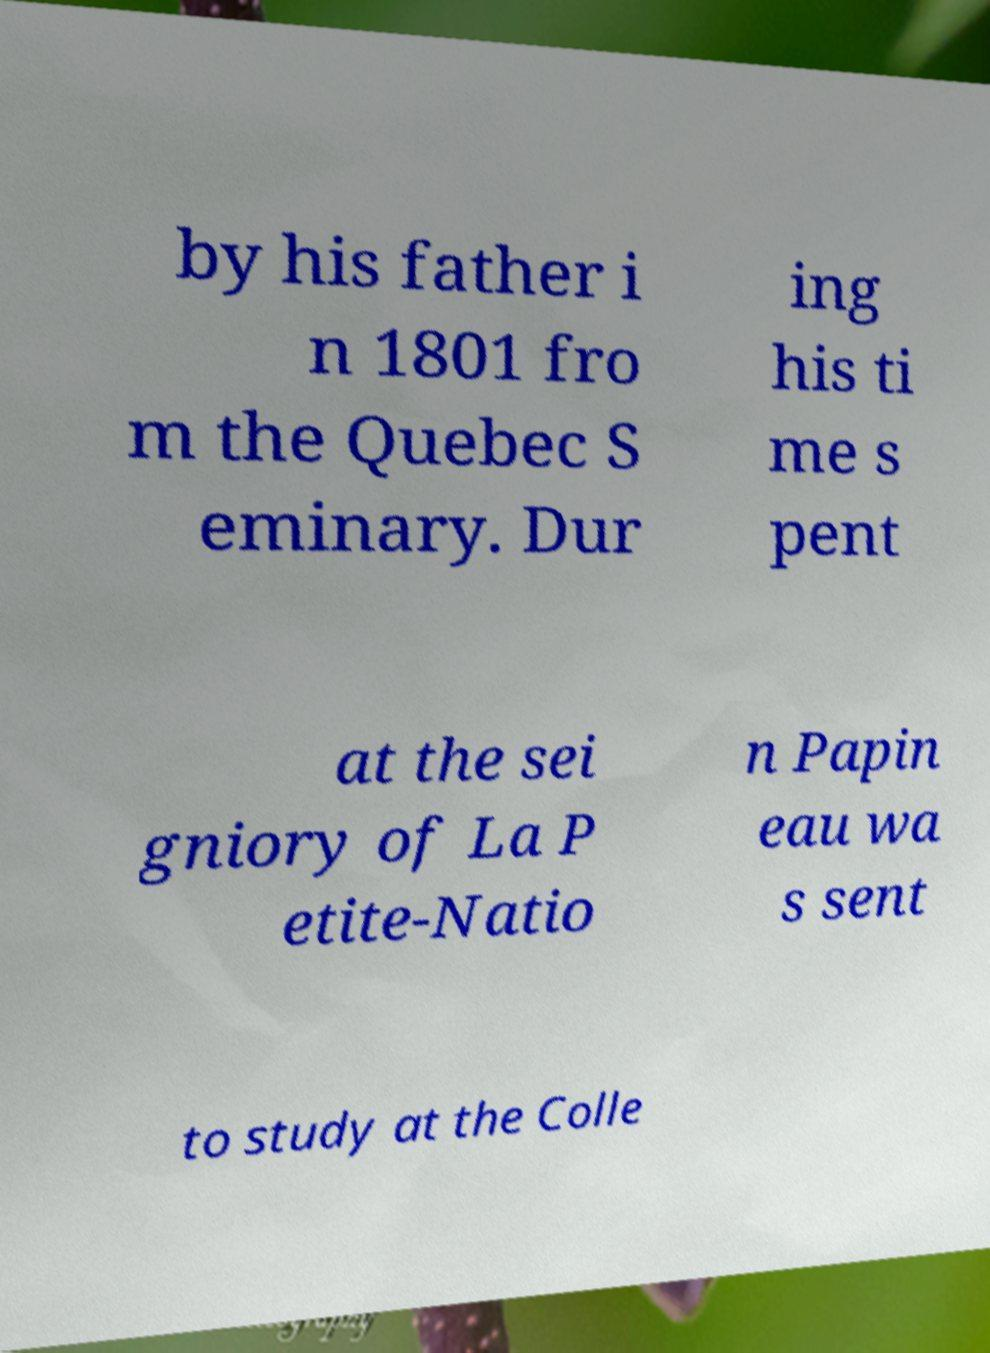Could you assist in decoding the text presented in this image and type it out clearly? by his father i n 1801 fro m the Quebec S eminary. Dur ing his ti me s pent at the sei gniory of La P etite-Natio n Papin eau wa s sent to study at the Colle 